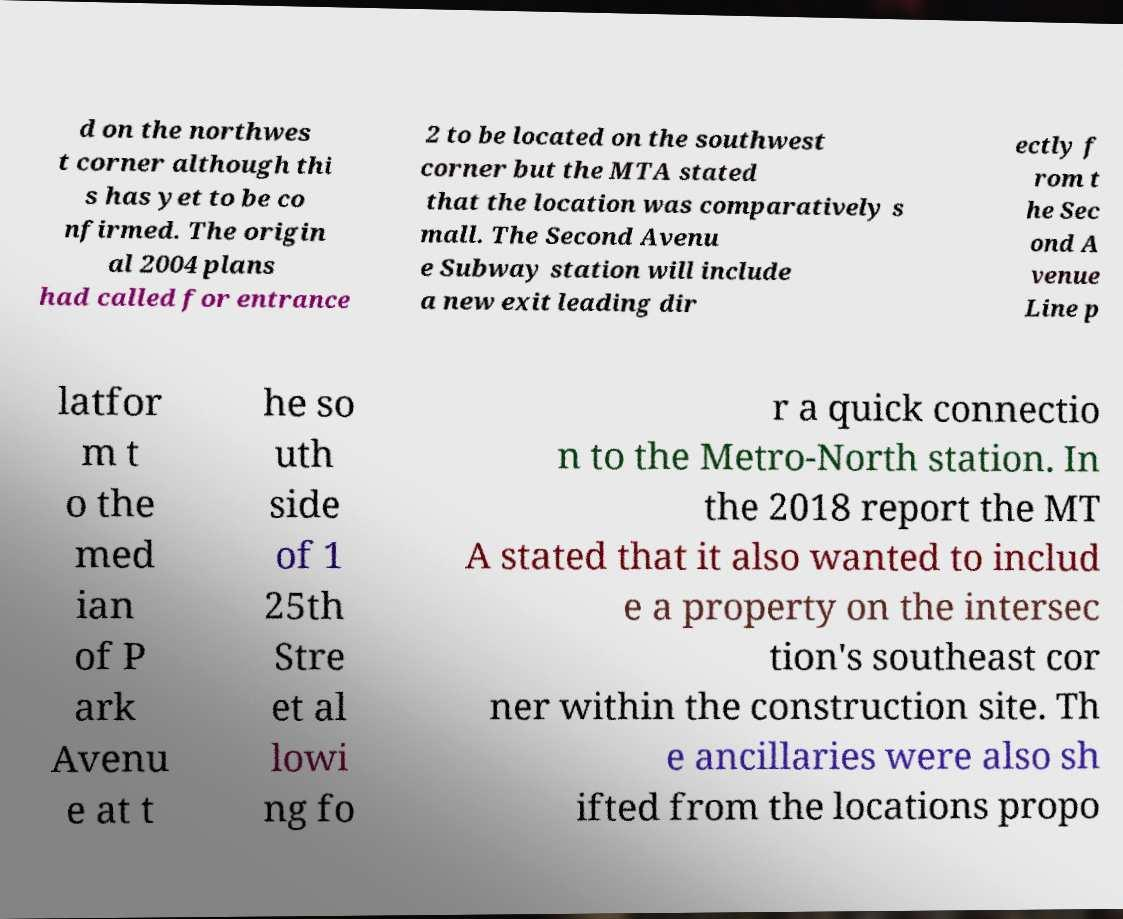For documentation purposes, I need the text within this image transcribed. Could you provide that? d on the northwes t corner although thi s has yet to be co nfirmed. The origin al 2004 plans had called for entrance 2 to be located on the southwest corner but the MTA stated that the location was comparatively s mall. The Second Avenu e Subway station will include a new exit leading dir ectly f rom t he Sec ond A venue Line p latfor m t o the med ian of P ark Avenu e at t he so uth side of 1 25th Stre et al lowi ng fo r a quick connectio n to the Metro-North station. In the 2018 report the MT A stated that it also wanted to includ e a property on the intersec tion's southeast cor ner within the construction site. Th e ancillaries were also sh ifted from the locations propo 